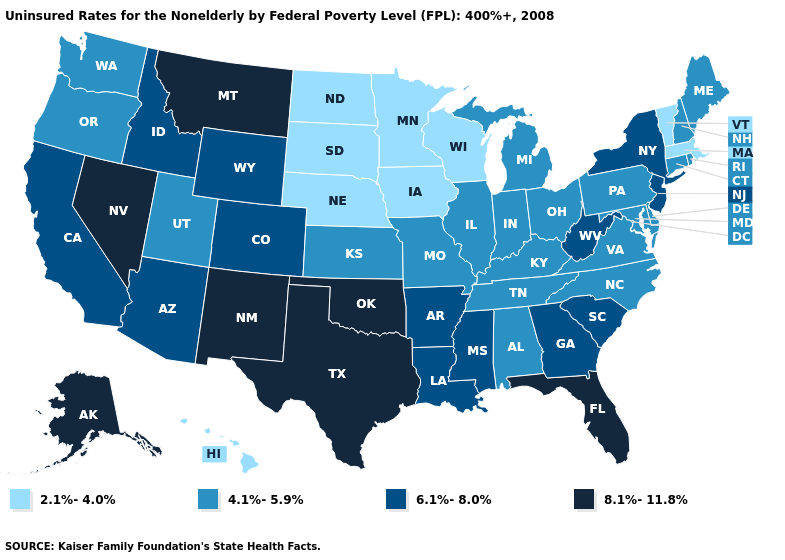Which states have the lowest value in the USA?
Short answer required. Hawaii, Iowa, Massachusetts, Minnesota, Nebraska, North Dakota, South Dakota, Vermont, Wisconsin. Name the states that have a value in the range 6.1%-8.0%?
Keep it brief. Arizona, Arkansas, California, Colorado, Georgia, Idaho, Louisiana, Mississippi, New Jersey, New York, South Carolina, West Virginia, Wyoming. What is the value of Hawaii?
Quick response, please. 2.1%-4.0%. Name the states that have a value in the range 4.1%-5.9%?
Short answer required. Alabama, Connecticut, Delaware, Illinois, Indiana, Kansas, Kentucky, Maine, Maryland, Michigan, Missouri, New Hampshire, North Carolina, Ohio, Oregon, Pennsylvania, Rhode Island, Tennessee, Utah, Virginia, Washington. What is the value of Utah?
Be succinct. 4.1%-5.9%. What is the lowest value in the MidWest?
Answer briefly. 2.1%-4.0%. What is the value of Georgia?
Be succinct. 6.1%-8.0%. Name the states that have a value in the range 2.1%-4.0%?
Be succinct. Hawaii, Iowa, Massachusetts, Minnesota, Nebraska, North Dakota, South Dakota, Vermont, Wisconsin. What is the value of Kansas?
Keep it brief. 4.1%-5.9%. Does Connecticut have a lower value than New Jersey?
Be succinct. Yes. What is the highest value in the West ?
Quick response, please. 8.1%-11.8%. Which states have the lowest value in the USA?
Be succinct. Hawaii, Iowa, Massachusetts, Minnesota, Nebraska, North Dakota, South Dakota, Vermont, Wisconsin. What is the value of Alaska?
Concise answer only. 8.1%-11.8%. Does Indiana have the lowest value in the MidWest?
Quick response, please. No. What is the highest value in the USA?
Keep it brief. 8.1%-11.8%. 